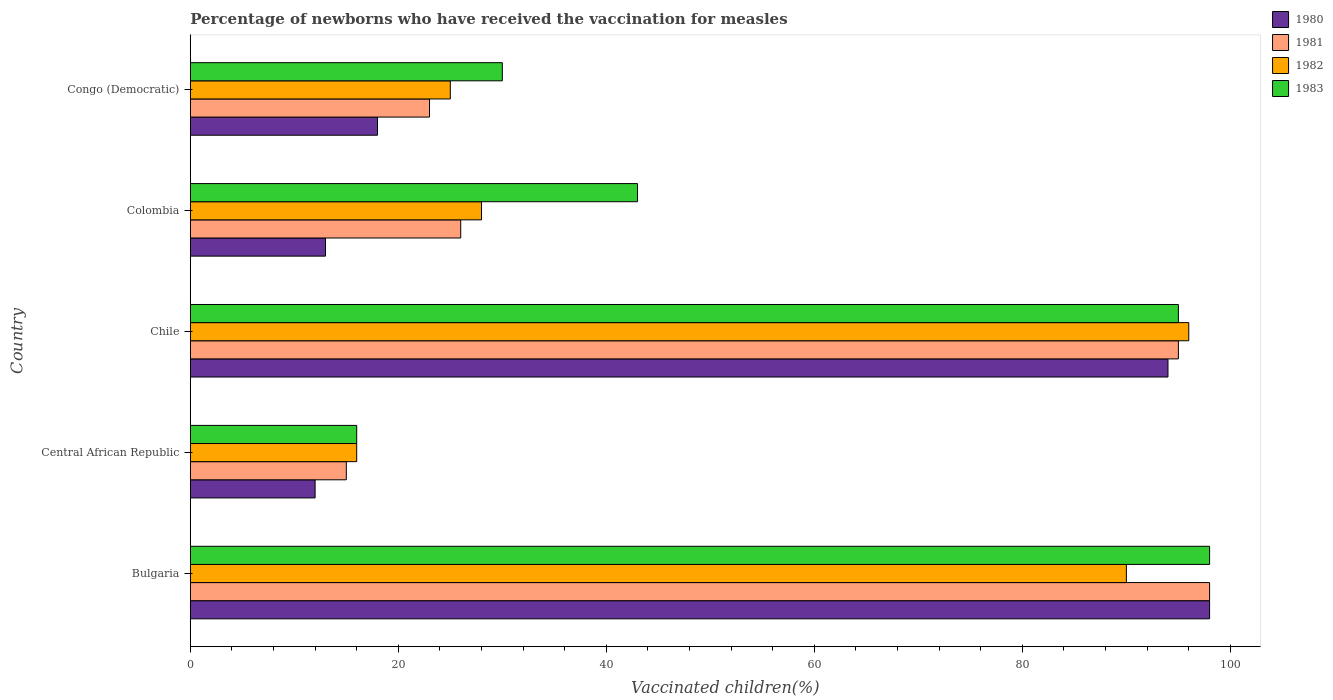How many different coloured bars are there?
Ensure brevity in your answer.  4. Are the number of bars per tick equal to the number of legend labels?
Provide a short and direct response. Yes. How many bars are there on the 1st tick from the top?
Make the answer very short. 4. What is the label of the 4th group of bars from the top?
Keep it short and to the point. Central African Republic. Across all countries, what is the maximum percentage of vaccinated children in 1983?
Keep it short and to the point. 98. Across all countries, what is the minimum percentage of vaccinated children in 1980?
Give a very brief answer. 12. In which country was the percentage of vaccinated children in 1980 minimum?
Ensure brevity in your answer.  Central African Republic. What is the total percentage of vaccinated children in 1983 in the graph?
Provide a short and direct response. 282. What is the difference between the percentage of vaccinated children in 1983 in Central African Republic and that in Congo (Democratic)?
Your answer should be very brief. -14. What is the difference between the percentage of vaccinated children in 1983 and percentage of vaccinated children in 1982 in Chile?
Your response must be concise. -1. What is the ratio of the percentage of vaccinated children in 1983 in Chile to that in Colombia?
Give a very brief answer. 2.21. Is the difference between the percentage of vaccinated children in 1983 in Bulgaria and Chile greater than the difference between the percentage of vaccinated children in 1982 in Bulgaria and Chile?
Keep it short and to the point. Yes. What is the difference between the highest and the lowest percentage of vaccinated children in 1980?
Offer a very short reply. 86. In how many countries, is the percentage of vaccinated children in 1983 greater than the average percentage of vaccinated children in 1983 taken over all countries?
Offer a very short reply. 2. Is the sum of the percentage of vaccinated children in 1982 in Bulgaria and Chile greater than the maximum percentage of vaccinated children in 1980 across all countries?
Provide a short and direct response. Yes. What does the 4th bar from the top in Chile represents?
Your response must be concise. 1980. What does the 3rd bar from the bottom in Colombia represents?
Provide a short and direct response. 1982. Is it the case that in every country, the sum of the percentage of vaccinated children in 1982 and percentage of vaccinated children in 1980 is greater than the percentage of vaccinated children in 1981?
Your answer should be very brief. Yes. How many bars are there?
Your response must be concise. 20. Are the values on the major ticks of X-axis written in scientific E-notation?
Offer a very short reply. No. Does the graph contain any zero values?
Provide a succinct answer. No. How many legend labels are there?
Provide a succinct answer. 4. How are the legend labels stacked?
Your answer should be very brief. Vertical. What is the title of the graph?
Offer a very short reply. Percentage of newborns who have received the vaccination for measles. Does "1990" appear as one of the legend labels in the graph?
Make the answer very short. No. What is the label or title of the X-axis?
Your answer should be compact. Vaccinated children(%). What is the Vaccinated children(%) of 1980 in Bulgaria?
Ensure brevity in your answer.  98. What is the Vaccinated children(%) in 1982 in Bulgaria?
Offer a very short reply. 90. What is the Vaccinated children(%) of 1980 in Central African Republic?
Your answer should be very brief. 12. What is the Vaccinated children(%) in 1981 in Central African Republic?
Your answer should be very brief. 15. What is the Vaccinated children(%) in 1980 in Chile?
Offer a terse response. 94. What is the Vaccinated children(%) in 1981 in Chile?
Give a very brief answer. 95. What is the Vaccinated children(%) in 1982 in Chile?
Provide a short and direct response. 96. What is the Vaccinated children(%) of 1983 in Chile?
Provide a succinct answer. 95. What is the Vaccinated children(%) in 1982 in Colombia?
Make the answer very short. 28. What is the Vaccinated children(%) of 1981 in Congo (Democratic)?
Your answer should be very brief. 23. Across all countries, what is the maximum Vaccinated children(%) of 1982?
Your answer should be very brief. 96. Across all countries, what is the minimum Vaccinated children(%) of 1982?
Ensure brevity in your answer.  16. What is the total Vaccinated children(%) of 1980 in the graph?
Your answer should be very brief. 235. What is the total Vaccinated children(%) in 1981 in the graph?
Give a very brief answer. 257. What is the total Vaccinated children(%) of 1982 in the graph?
Make the answer very short. 255. What is the total Vaccinated children(%) of 1983 in the graph?
Your answer should be compact. 282. What is the difference between the Vaccinated children(%) in 1982 in Bulgaria and that in Central African Republic?
Give a very brief answer. 74. What is the difference between the Vaccinated children(%) of 1983 in Bulgaria and that in Central African Republic?
Give a very brief answer. 82. What is the difference between the Vaccinated children(%) in 1980 in Bulgaria and that in Chile?
Give a very brief answer. 4. What is the difference between the Vaccinated children(%) in 1981 in Bulgaria and that in Chile?
Make the answer very short. 3. What is the difference between the Vaccinated children(%) in 1980 in Bulgaria and that in Congo (Democratic)?
Make the answer very short. 80. What is the difference between the Vaccinated children(%) in 1981 in Bulgaria and that in Congo (Democratic)?
Keep it short and to the point. 75. What is the difference between the Vaccinated children(%) of 1983 in Bulgaria and that in Congo (Democratic)?
Give a very brief answer. 68. What is the difference between the Vaccinated children(%) of 1980 in Central African Republic and that in Chile?
Offer a very short reply. -82. What is the difference between the Vaccinated children(%) of 1981 in Central African Republic and that in Chile?
Make the answer very short. -80. What is the difference between the Vaccinated children(%) of 1982 in Central African Republic and that in Chile?
Your response must be concise. -80. What is the difference between the Vaccinated children(%) of 1983 in Central African Republic and that in Chile?
Ensure brevity in your answer.  -79. What is the difference between the Vaccinated children(%) of 1980 in Central African Republic and that in Colombia?
Provide a succinct answer. -1. What is the difference between the Vaccinated children(%) in 1981 in Central African Republic and that in Colombia?
Offer a terse response. -11. What is the difference between the Vaccinated children(%) in 1980 in Central African Republic and that in Congo (Democratic)?
Ensure brevity in your answer.  -6. What is the difference between the Vaccinated children(%) in 1982 in Central African Republic and that in Congo (Democratic)?
Ensure brevity in your answer.  -9. What is the difference between the Vaccinated children(%) in 1980 in Chile and that in Congo (Democratic)?
Make the answer very short. 76. What is the difference between the Vaccinated children(%) in 1983 in Chile and that in Congo (Democratic)?
Your answer should be compact. 65. What is the difference between the Vaccinated children(%) of 1980 in Colombia and that in Congo (Democratic)?
Provide a succinct answer. -5. What is the difference between the Vaccinated children(%) in 1980 in Bulgaria and the Vaccinated children(%) in 1982 in Central African Republic?
Give a very brief answer. 82. What is the difference between the Vaccinated children(%) of 1980 in Bulgaria and the Vaccinated children(%) of 1982 in Chile?
Offer a very short reply. 2. What is the difference between the Vaccinated children(%) in 1980 in Bulgaria and the Vaccinated children(%) in 1983 in Chile?
Offer a terse response. 3. What is the difference between the Vaccinated children(%) in 1981 in Bulgaria and the Vaccinated children(%) in 1983 in Chile?
Provide a short and direct response. 3. What is the difference between the Vaccinated children(%) in 1982 in Bulgaria and the Vaccinated children(%) in 1983 in Chile?
Make the answer very short. -5. What is the difference between the Vaccinated children(%) in 1980 in Bulgaria and the Vaccinated children(%) in 1981 in Colombia?
Offer a very short reply. 72. What is the difference between the Vaccinated children(%) in 1980 in Bulgaria and the Vaccinated children(%) in 1982 in Colombia?
Give a very brief answer. 70. What is the difference between the Vaccinated children(%) in 1981 in Bulgaria and the Vaccinated children(%) in 1982 in Colombia?
Your answer should be very brief. 70. What is the difference between the Vaccinated children(%) of 1980 in Central African Republic and the Vaccinated children(%) of 1981 in Chile?
Keep it short and to the point. -83. What is the difference between the Vaccinated children(%) of 1980 in Central African Republic and the Vaccinated children(%) of 1982 in Chile?
Provide a succinct answer. -84. What is the difference between the Vaccinated children(%) in 1980 in Central African Republic and the Vaccinated children(%) in 1983 in Chile?
Your response must be concise. -83. What is the difference between the Vaccinated children(%) in 1981 in Central African Republic and the Vaccinated children(%) in 1982 in Chile?
Offer a very short reply. -81. What is the difference between the Vaccinated children(%) in 1981 in Central African Republic and the Vaccinated children(%) in 1983 in Chile?
Your response must be concise. -80. What is the difference between the Vaccinated children(%) of 1982 in Central African Republic and the Vaccinated children(%) of 1983 in Chile?
Provide a short and direct response. -79. What is the difference between the Vaccinated children(%) of 1980 in Central African Republic and the Vaccinated children(%) of 1981 in Colombia?
Your answer should be very brief. -14. What is the difference between the Vaccinated children(%) of 1980 in Central African Republic and the Vaccinated children(%) of 1982 in Colombia?
Provide a succinct answer. -16. What is the difference between the Vaccinated children(%) of 1980 in Central African Republic and the Vaccinated children(%) of 1983 in Colombia?
Give a very brief answer. -31. What is the difference between the Vaccinated children(%) of 1981 in Central African Republic and the Vaccinated children(%) of 1983 in Colombia?
Offer a terse response. -28. What is the difference between the Vaccinated children(%) in 1980 in Central African Republic and the Vaccinated children(%) in 1981 in Congo (Democratic)?
Ensure brevity in your answer.  -11. What is the difference between the Vaccinated children(%) of 1980 in Central African Republic and the Vaccinated children(%) of 1982 in Congo (Democratic)?
Your response must be concise. -13. What is the difference between the Vaccinated children(%) in 1980 in Central African Republic and the Vaccinated children(%) in 1983 in Congo (Democratic)?
Provide a short and direct response. -18. What is the difference between the Vaccinated children(%) in 1981 in Central African Republic and the Vaccinated children(%) in 1982 in Congo (Democratic)?
Your response must be concise. -10. What is the difference between the Vaccinated children(%) in 1981 in Central African Republic and the Vaccinated children(%) in 1983 in Congo (Democratic)?
Your answer should be compact. -15. What is the difference between the Vaccinated children(%) of 1982 in Central African Republic and the Vaccinated children(%) of 1983 in Congo (Democratic)?
Give a very brief answer. -14. What is the difference between the Vaccinated children(%) in 1980 in Chile and the Vaccinated children(%) in 1983 in Colombia?
Keep it short and to the point. 51. What is the difference between the Vaccinated children(%) in 1980 in Chile and the Vaccinated children(%) in 1982 in Congo (Democratic)?
Make the answer very short. 69. What is the difference between the Vaccinated children(%) of 1982 in Chile and the Vaccinated children(%) of 1983 in Congo (Democratic)?
Provide a short and direct response. 66. What is the difference between the Vaccinated children(%) in 1980 in Colombia and the Vaccinated children(%) in 1981 in Congo (Democratic)?
Offer a terse response. -10. What is the difference between the Vaccinated children(%) in 1980 in Colombia and the Vaccinated children(%) in 1983 in Congo (Democratic)?
Your answer should be very brief. -17. What is the difference between the Vaccinated children(%) of 1981 in Colombia and the Vaccinated children(%) of 1982 in Congo (Democratic)?
Your answer should be very brief. 1. What is the difference between the Vaccinated children(%) of 1981 in Colombia and the Vaccinated children(%) of 1983 in Congo (Democratic)?
Provide a succinct answer. -4. What is the average Vaccinated children(%) in 1980 per country?
Your answer should be compact. 47. What is the average Vaccinated children(%) in 1981 per country?
Your answer should be compact. 51.4. What is the average Vaccinated children(%) in 1983 per country?
Your answer should be compact. 56.4. What is the difference between the Vaccinated children(%) of 1980 and Vaccinated children(%) of 1982 in Bulgaria?
Your answer should be compact. 8. What is the difference between the Vaccinated children(%) of 1981 and Vaccinated children(%) of 1983 in Bulgaria?
Give a very brief answer. 0. What is the difference between the Vaccinated children(%) of 1980 and Vaccinated children(%) of 1981 in Central African Republic?
Ensure brevity in your answer.  -3. What is the difference between the Vaccinated children(%) of 1980 and Vaccinated children(%) of 1982 in Central African Republic?
Offer a terse response. -4. What is the difference between the Vaccinated children(%) in 1981 and Vaccinated children(%) in 1982 in Central African Republic?
Keep it short and to the point. -1. What is the difference between the Vaccinated children(%) of 1981 and Vaccinated children(%) of 1983 in Central African Republic?
Ensure brevity in your answer.  -1. What is the difference between the Vaccinated children(%) of 1980 and Vaccinated children(%) of 1982 in Chile?
Your response must be concise. -2. What is the difference between the Vaccinated children(%) of 1980 and Vaccinated children(%) of 1983 in Chile?
Your answer should be very brief. -1. What is the difference between the Vaccinated children(%) in 1981 and Vaccinated children(%) in 1983 in Chile?
Offer a terse response. 0. What is the difference between the Vaccinated children(%) of 1982 and Vaccinated children(%) of 1983 in Chile?
Your answer should be very brief. 1. What is the difference between the Vaccinated children(%) of 1980 and Vaccinated children(%) of 1981 in Colombia?
Your response must be concise. -13. What is the difference between the Vaccinated children(%) in 1980 and Vaccinated children(%) in 1982 in Colombia?
Your answer should be very brief. -15. What is the difference between the Vaccinated children(%) in 1980 and Vaccinated children(%) in 1983 in Colombia?
Offer a very short reply. -30. What is the difference between the Vaccinated children(%) of 1981 and Vaccinated children(%) of 1982 in Colombia?
Provide a succinct answer. -2. What is the difference between the Vaccinated children(%) of 1980 and Vaccinated children(%) of 1981 in Congo (Democratic)?
Your response must be concise. -5. What is the difference between the Vaccinated children(%) in 1980 and Vaccinated children(%) in 1982 in Congo (Democratic)?
Your answer should be very brief. -7. What is the difference between the Vaccinated children(%) of 1982 and Vaccinated children(%) of 1983 in Congo (Democratic)?
Offer a very short reply. -5. What is the ratio of the Vaccinated children(%) of 1980 in Bulgaria to that in Central African Republic?
Ensure brevity in your answer.  8.17. What is the ratio of the Vaccinated children(%) in 1981 in Bulgaria to that in Central African Republic?
Your response must be concise. 6.53. What is the ratio of the Vaccinated children(%) in 1982 in Bulgaria to that in Central African Republic?
Keep it short and to the point. 5.62. What is the ratio of the Vaccinated children(%) in 1983 in Bulgaria to that in Central African Republic?
Your response must be concise. 6.12. What is the ratio of the Vaccinated children(%) in 1980 in Bulgaria to that in Chile?
Give a very brief answer. 1.04. What is the ratio of the Vaccinated children(%) in 1981 in Bulgaria to that in Chile?
Your answer should be compact. 1.03. What is the ratio of the Vaccinated children(%) in 1983 in Bulgaria to that in Chile?
Your answer should be compact. 1.03. What is the ratio of the Vaccinated children(%) of 1980 in Bulgaria to that in Colombia?
Provide a succinct answer. 7.54. What is the ratio of the Vaccinated children(%) of 1981 in Bulgaria to that in Colombia?
Give a very brief answer. 3.77. What is the ratio of the Vaccinated children(%) of 1982 in Bulgaria to that in Colombia?
Ensure brevity in your answer.  3.21. What is the ratio of the Vaccinated children(%) of 1983 in Bulgaria to that in Colombia?
Provide a short and direct response. 2.28. What is the ratio of the Vaccinated children(%) of 1980 in Bulgaria to that in Congo (Democratic)?
Offer a very short reply. 5.44. What is the ratio of the Vaccinated children(%) in 1981 in Bulgaria to that in Congo (Democratic)?
Make the answer very short. 4.26. What is the ratio of the Vaccinated children(%) in 1982 in Bulgaria to that in Congo (Democratic)?
Make the answer very short. 3.6. What is the ratio of the Vaccinated children(%) of 1983 in Bulgaria to that in Congo (Democratic)?
Provide a succinct answer. 3.27. What is the ratio of the Vaccinated children(%) in 1980 in Central African Republic to that in Chile?
Offer a very short reply. 0.13. What is the ratio of the Vaccinated children(%) in 1981 in Central African Republic to that in Chile?
Your response must be concise. 0.16. What is the ratio of the Vaccinated children(%) of 1982 in Central African Republic to that in Chile?
Offer a very short reply. 0.17. What is the ratio of the Vaccinated children(%) of 1983 in Central African Republic to that in Chile?
Offer a terse response. 0.17. What is the ratio of the Vaccinated children(%) in 1981 in Central African Republic to that in Colombia?
Your answer should be compact. 0.58. What is the ratio of the Vaccinated children(%) in 1982 in Central African Republic to that in Colombia?
Your response must be concise. 0.57. What is the ratio of the Vaccinated children(%) in 1983 in Central African Republic to that in Colombia?
Your response must be concise. 0.37. What is the ratio of the Vaccinated children(%) in 1981 in Central African Republic to that in Congo (Democratic)?
Your response must be concise. 0.65. What is the ratio of the Vaccinated children(%) of 1982 in Central African Republic to that in Congo (Democratic)?
Make the answer very short. 0.64. What is the ratio of the Vaccinated children(%) in 1983 in Central African Republic to that in Congo (Democratic)?
Give a very brief answer. 0.53. What is the ratio of the Vaccinated children(%) of 1980 in Chile to that in Colombia?
Your response must be concise. 7.23. What is the ratio of the Vaccinated children(%) in 1981 in Chile to that in Colombia?
Keep it short and to the point. 3.65. What is the ratio of the Vaccinated children(%) in 1982 in Chile to that in Colombia?
Provide a succinct answer. 3.43. What is the ratio of the Vaccinated children(%) in 1983 in Chile to that in Colombia?
Offer a terse response. 2.21. What is the ratio of the Vaccinated children(%) of 1980 in Chile to that in Congo (Democratic)?
Keep it short and to the point. 5.22. What is the ratio of the Vaccinated children(%) of 1981 in Chile to that in Congo (Democratic)?
Ensure brevity in your answer.  4.13. What is the ratio of the Vaccinated children(%) in 1982 in Chile to that in Congo (Democratic)?
Give a very brief answer. 3.84. What is the ratio of the Vaccinated children(%) of 1983 in Chile to that in Congo (Democratic)?
Your answer should be compact. 3.17. What is the ratio of the Vaccinated children(%) of 1980 in Colombia to that in Congo (Democratic)?
Provide a succinct answer. 0.72. What is the ratio of the Vaccinated children(%) of 1981 in Colombia to that in Congo (Democratic)?
Your answer should be very brief. 1.13. What is the ratio of the Vaccinated children(%) in 1982 in Colombia to that in Congo (Democratic)?
Your answer should be compact. 1.12. What is the ratio of the Vaccinated children(%) of 1983 in Colombia to that in Congo (Democratic)?
Offer a terse response. 1.43. What is the difference between the highest and the second highest Vaccinated children(%) of 1981?
Give a very brief answer. 3. What is the difference between the highest and the lowest Vaccinated children(%) in 1980?
Offer a terse response. 86. What is the difference between the highest and the lowest Vaccinated children(%) in 1981?
Keep it short and to the point. 83. What is the difference between the highest and the lowest Vaccinated children(%) in 1982?
Keep it short and to the point. 80. What is the difference between the highest and the lowest Vaccinated children(%) in 1983?
Your answer should be very brief. 82. 